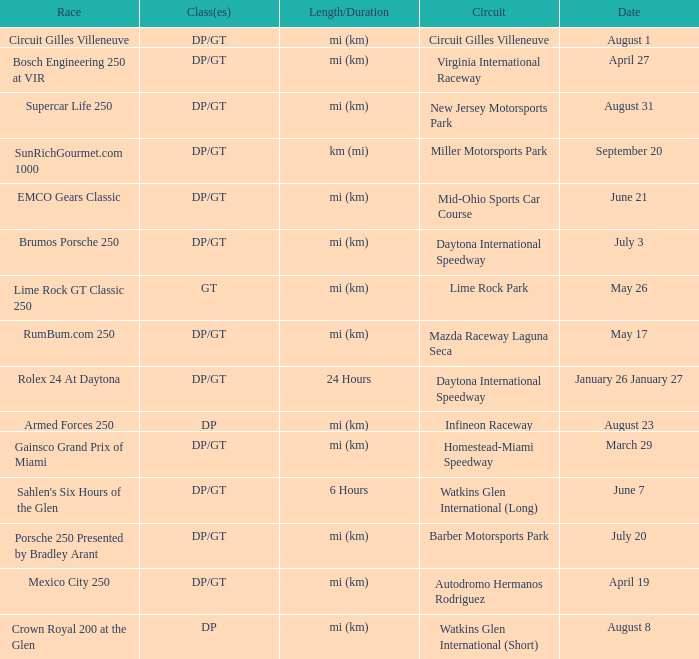What was the date of the race that lasted 6 hours? June 7. 